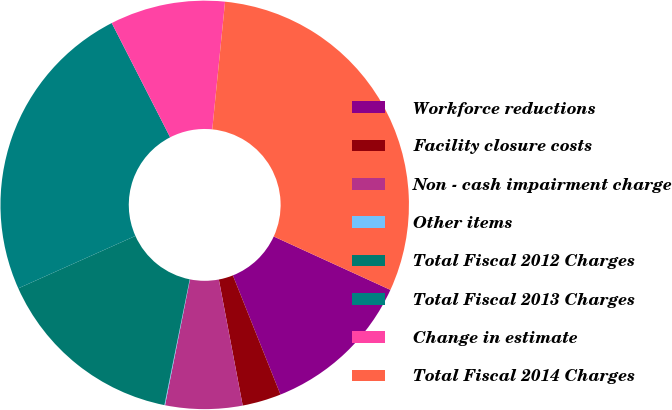Convert chart to OTSL. <chart><loc_0><loc_0><loc_500><loc_500><pie_chart><fcel>Workforce reductions<fcel>Facility closure costs<fcel>Non - cash impairment charge<fcel>Other items<fcel>Total Fiscal 2012 Charges<fcel>Total Fiscal 2013 Charges<fcel>Change in estimate<fcel>Total Fiscal 2014 Charges<nl><fcel>12.12%<fcel>3.07%<fcel>6.09%<fcel>0.05%<fcel>15.14%<fcel>24.18%<fcel>9.11%<fcel>30.24%<nl></chart> 